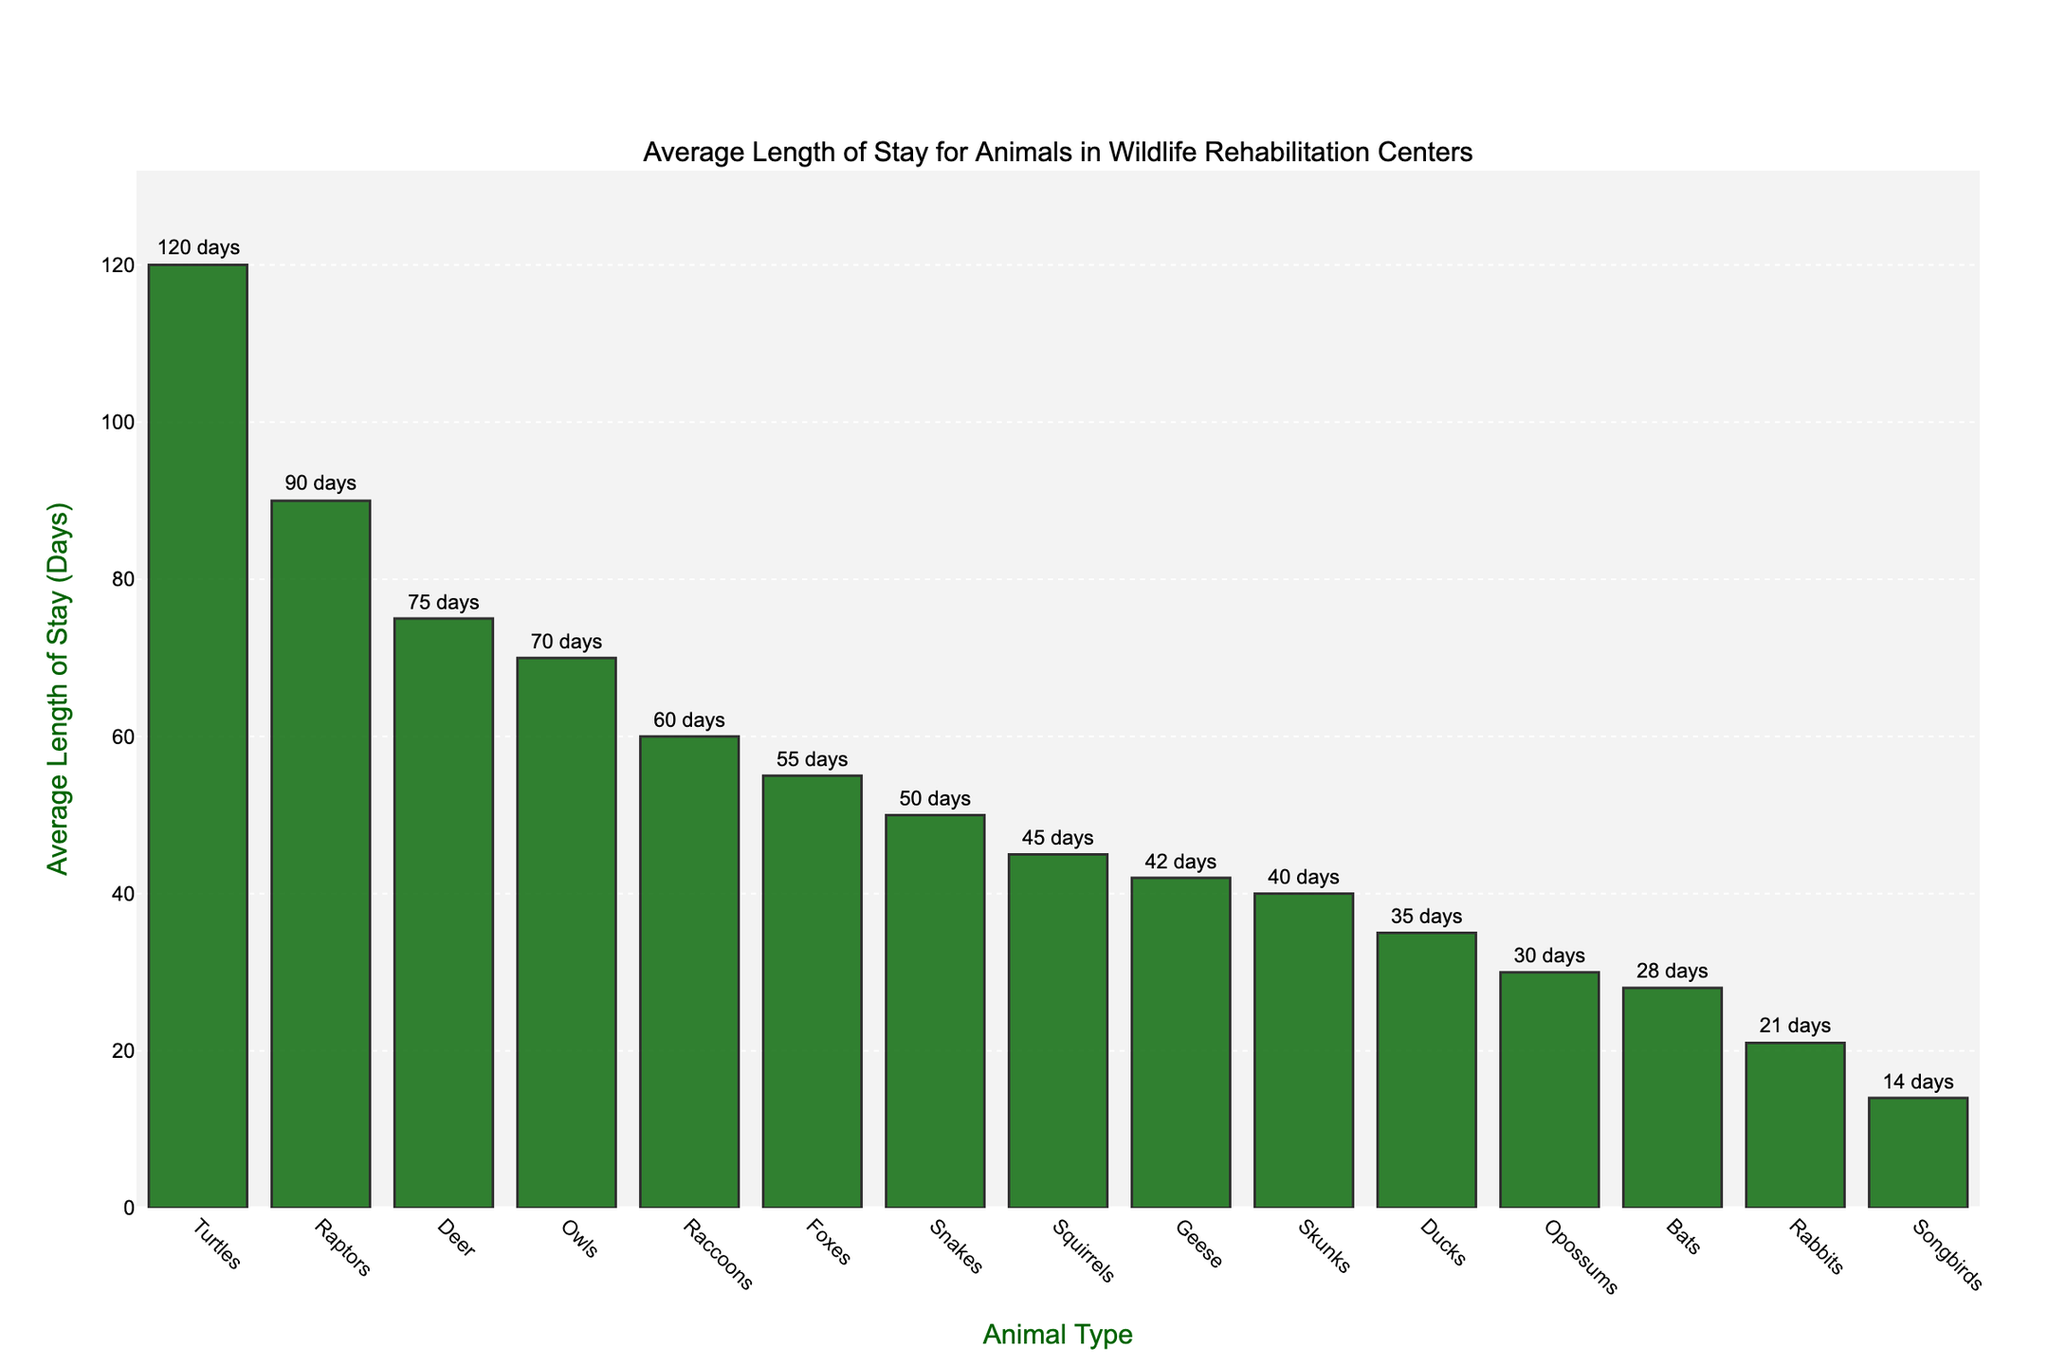Which animal type has the longest average stay in wildlife rehabilitation centers? The bar representing Turtles is the tallest in the chart, indicating that Turtles have the longest average stay.
Answer: Turtles What is the difference in the average length of stay between Raccoons and Rabbits? The bar for Raccoons shows 60 days, and the bar for Rabbits shows 21 days. Subtract the smaller value from the larger one: 60 - 21 = 39.
Answer: 39 days How many animal types have an average stay of more than 50 days? Looking at the bars, we identify Turtles (120), Raptors (90), Deer (75), Owls (70), Raccoons (60), Foxes (55), and Snakes (50). However, Snakes have exactly 50, so it does not count. The total becomes 6: Turtles, Raptors, Deer, Owls, Raccoons, and Foxes.
Answer: 6 Which animal has a shorter average stay, Bats or Geese? By comparing the heights of the bars for Bats and Geese, Bats have an average stay of 28 days, whereas Geese have 42 days, making Bats' stay shorter.
Answer: Bats What is the combined average length of stay for all bird types listed (Songbirds, Raptors, Owls, Ducks, Geese)? Find each bird and sum their stay durations: Songbirds (14) + Raptors (90) + Owls (70) + Ducks (35) + Geese (42) = 251 days.
Answer: 251 days Which animal has an average stay closest to the average stay of all animals combined in the figure? Calculate the total length of stay and divide it by the number of animal types: (45 + 60 + 30 + 21 + 14 + 90 + 75 + 55 + 28 + 120 + 40 + 70 + 35 + 42 + 50) / 15 = 48.7 days. The animal type with an average closest to 48.7 is Skunks, which have 40 days.
Answer: Skunks How does the average stay of Squirrels compare to the overall average stay of all animals? The overall average stay is 48.7 days. Comparing this with the average stay of Squirrels, which is 45 days, Squirrels stay on average 3.7 days less than the overall average.
Answer: Squirrels stay 3.7 days less What’s the median length of stay for all animal types? List the stays in ascending order: 14, 21, 28, 30, 35, 40, 42, 45, 50, 55, 60, 70, 75, 90, 120. The median is the middle value in this list, which is 45.
Answer: 45 days 